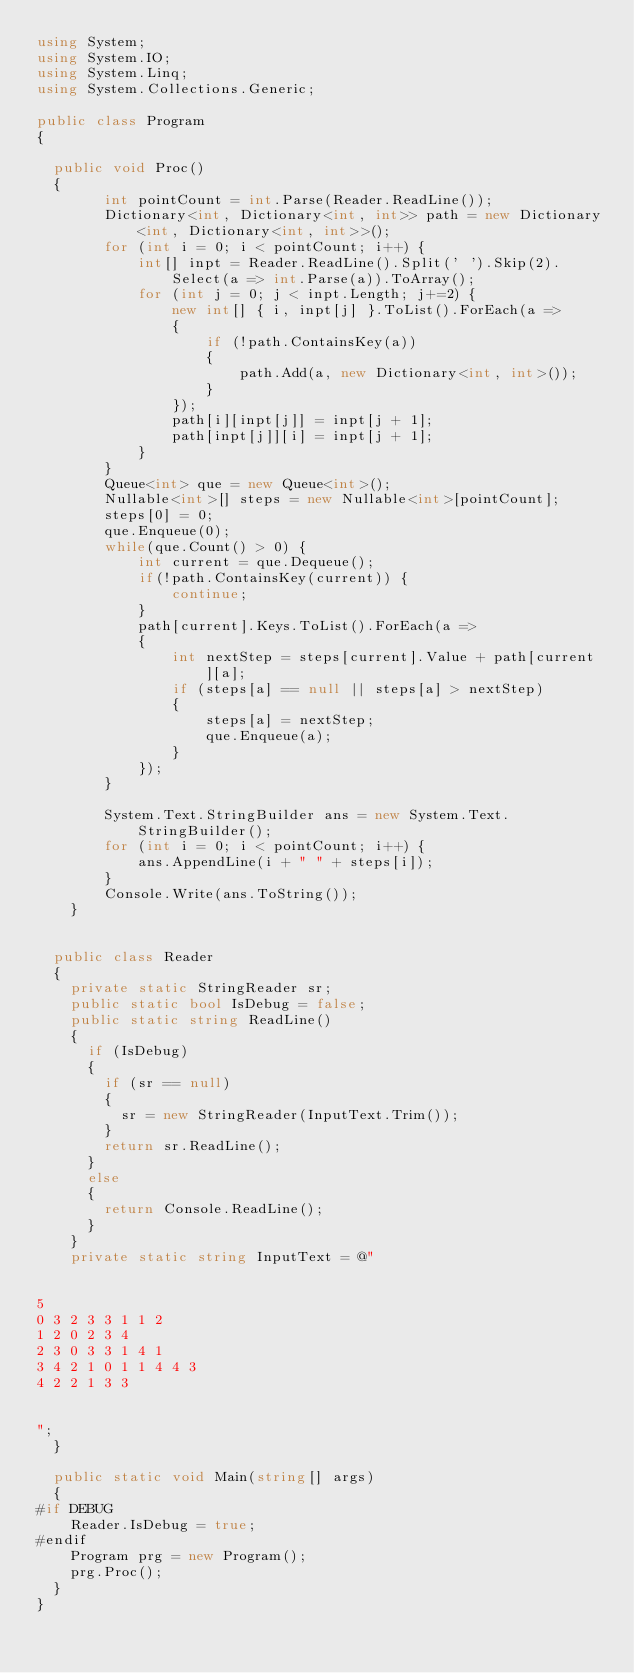Convert code to text. <code><loc_0><loc_0><loc_500><loc_500><_C#_>using System;
using System.IO;
using System.Linq;
using System.Collections.Generic;

public class Program
{

	public void Proc()
	{
        int pointCount = int.Parse(Reader.ReadLine());
        Dictionary<int, Dictionary<int, int>> path = new Dictionary<int, Dictionary<int, int>>();
        for (int i = 0; i < pointCount; i++) {
            int[] inpt = Reader.ReadLine().Split(' ').Skip(2).Select(a => int.Parse(a)).ToArray();
            for (int j = 0; j < inpt.Length; j+=2) {
                new int[] { i, inpt[j] }.ToList().ForEach(a =>
                {
                    if (!path.ContainsKey(a))
                    {
                        path.Add(a, new Dictionary<int, int>());
                    }
                });
                path[i][inpt[j]] = inpt[j + 1];
                path[inpt[j]][i] = inpt[j + 1];
            }
        }
        Queue<int> que = new Queue<int>();
        Nullable<int>[] steps = new Nullable<int>[pointCount];
        steps[0] = 0;
        que.Enqueue(0);
        while(que.Count() > 0) {
            int current = que.Dequeue();
            if(!path.ContainsKey(current)) {
                continue;
            }
            path[current].Keys.ToList().ForEach(a =>
            {
                int nextStep = steps[current].Value + path[current][a];
                if (steps[a] == null || steps[a] > nextStep)
                {
                    steps[a] = nextStep;
                    que.Enqueue(a);
                }
            });
        }

        System.Text.StringBuilder ans = new System.Text.StringBuilder();
        for (int i = 0; i < pointCount; i++) {
            ans.AppendLine(i + " " + steps[i]);
        }
        Console.Write(ans.ToString());
    }


	public class Reader
	{
		private static StringReader sr;
		public static bool IsDebug = false;
		public static string ReadLine()
		{
			if (IsDebug)
			{
				if (sr == null)
				{
					sr = new StringReader(InputText.Trim());
				}
				return sr.ReadLine();
			}
			else
			{
				return Console.ReadLine();
			}
		}
		private static string InputText = @"


5
0 3 2 3 3 1 1 2
1 2 0 2 3 4
2 3 0 3 3 1 4 1
3 4 2 1 0 1 1 4 4 3
4 2 2 1 3 3


";
	}

	public static void Main(string[] args)
	{
#if DEBUG
		Reader.IsDebug = true;
#endif
		Program prg = new Program();
		prg.Proc();
	}
}</code> 